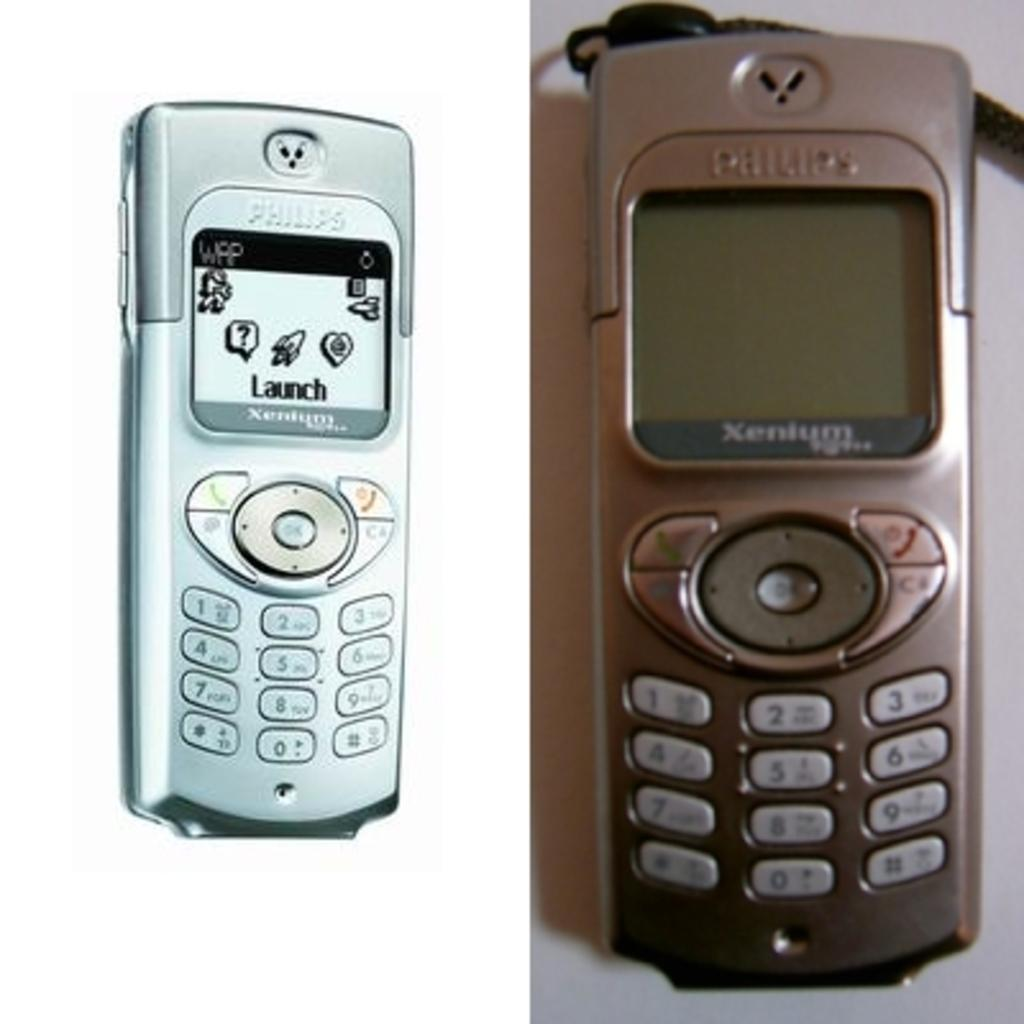<image>
Write a terse but informative summary of the picture. Two images of a Philips phone in different colors. 